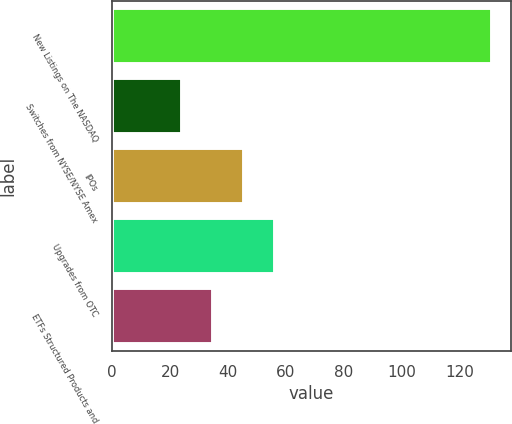Convert chart to OTSL. <chart><loc_0><loc_0><loc_500><loc_500><bar_chart><fcel>New Listings on The NASDAQ<fcel>Switches from NYSE/NYSE Amex<fcel>IPOs<fcel>Upgrades from OTC<fcel>ETFs Structured Products and<nl><fcel>131<fcel>24<fcel>45.4<fcel>56.1<fcel>34.7<nl></chart> 